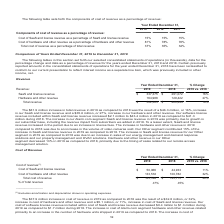According to Alarmcom Holdings's financial document, What was the increase in the company's Alarm.com segment SaaS and license revenue in 2019 was primarily due to? growth in our subscriber base, including the revenue impact from subscribers we added in 2018.. The document states: "S and license revenue in 2019 was primarily due to growth in our subscriber base, including the revenue impact from subscribers we added in 2018. To a..." Also, Why was there an increase in hardware and other revenue in 2019 compared to 2018? due to an increase in the volume of video cameras sold.. The document states: "are and other revenue in 2019 compared to 2018 was due to an increase in the volume of video cameras sold. Our Other segment contributed 15% of the in..." Also, What was the SaaS and license revenue in 2019? According to the financial document, $337,375 (in thousands). The relevant text states: "019 2018 2019 vs. 2018 SaaS and license revenue $ 337,375 $ 291,072 16% Hardware and other revenue 164,988 129,422 27% Total revenue $ 502,363 $ 420,494 19%..." Also, How many years did SaaS and license revenue exceed $300,000 thousand? Based on the analysis, there are 1 instances. The counting process: 2019. Also, How many components of revenue exceeded $200,000 thousand in 2018? Based on the analysis, there are 1 instances. The counting process: SaaS and license revenue. Also, can you calculate: What was SaaS and license revenue as a percentage of total revenue in 2019? Based on the calculation: 337,375/502,363, the result is 67.16 (percentage). This is based on the information: "019 2018 2019 vs. 2018 SaaS and license revenue $ 337,375 $ 291,072 16% Hardware and other revenue 164,988 129,422 27% Total revenue $ 502,363 $ 420,494 19% other revenue 164,988 129,422 27% Total rev..." The key data points involved are: 337,375, 502,363. 